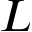<formula> <loc_0><loc_0><loc_500><loc_500>L</formula> 